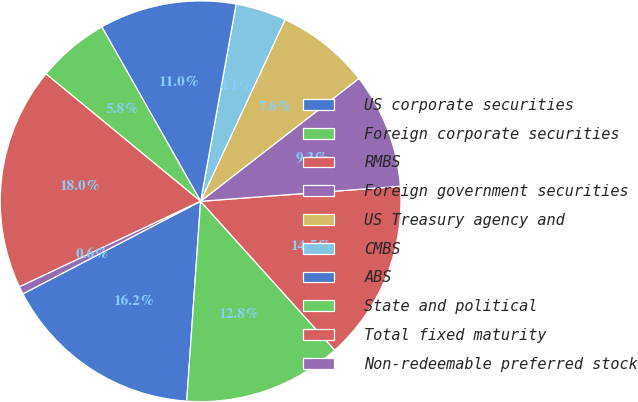Convert chart to OTSL. <chart><loc_0><loc_0><loc_500><loc_500><pie_chart><fcel>US corporate securities<fcel>Foreign corporate securities<fcel>RMBS<fcel>Foreign government securities<fcel>US Treasury agency and<fcel>CMBS<fcel>ABS<fcel>State and political<fcel>Total fixed maturity<fcel>Non-redeemable preferred stock<nl><fcel>16.25%<fcel>12.78%<fcel>14.52%<fcel>9.31%<fcel>7.57%<fcel>4.09%<fcel>11.04%<fcel>5.83%<fcel>17.99%<fcel>0.62%<nl></chart> 